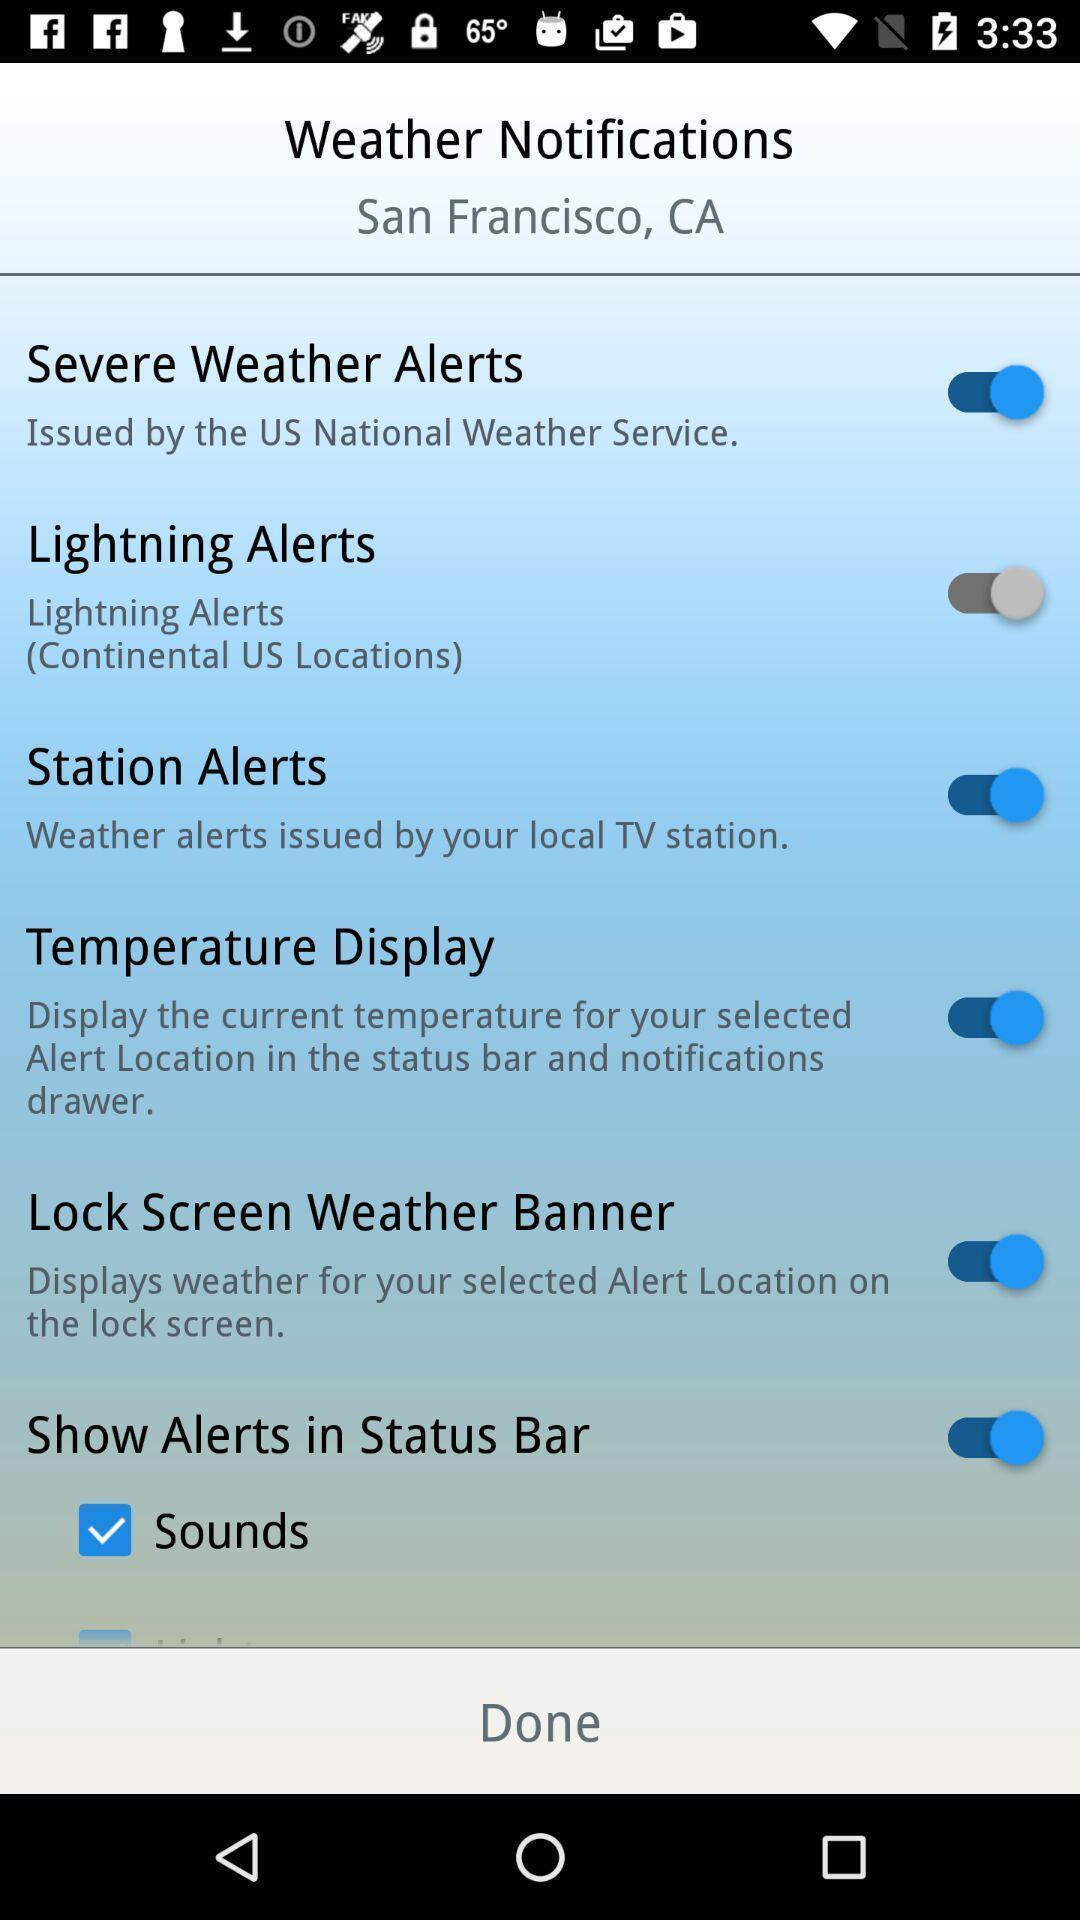What can you discern from this picture? Weather notifications page in a weather app. 